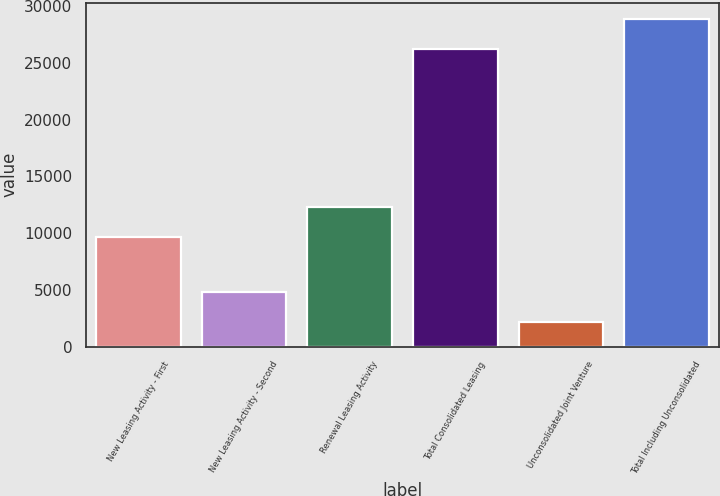Convert chart. <chart><loc_0><loc_0><loc_500><loc_500><bar_chart><fcel>New Leasing Activity - First<fcel>New Leasing Activity - Second<fcel>Renewal Leasing Activity<fcel>Total Consolidated Leasing<fcel>Unconsolidated Joint Venture<fcel>Total Including Unconsolidated<nl><fcel>9681<fcel>4852.1<fcel>12305.1<fcel>26241<fcel>2228<fcel>28865.1<nl></chart> 